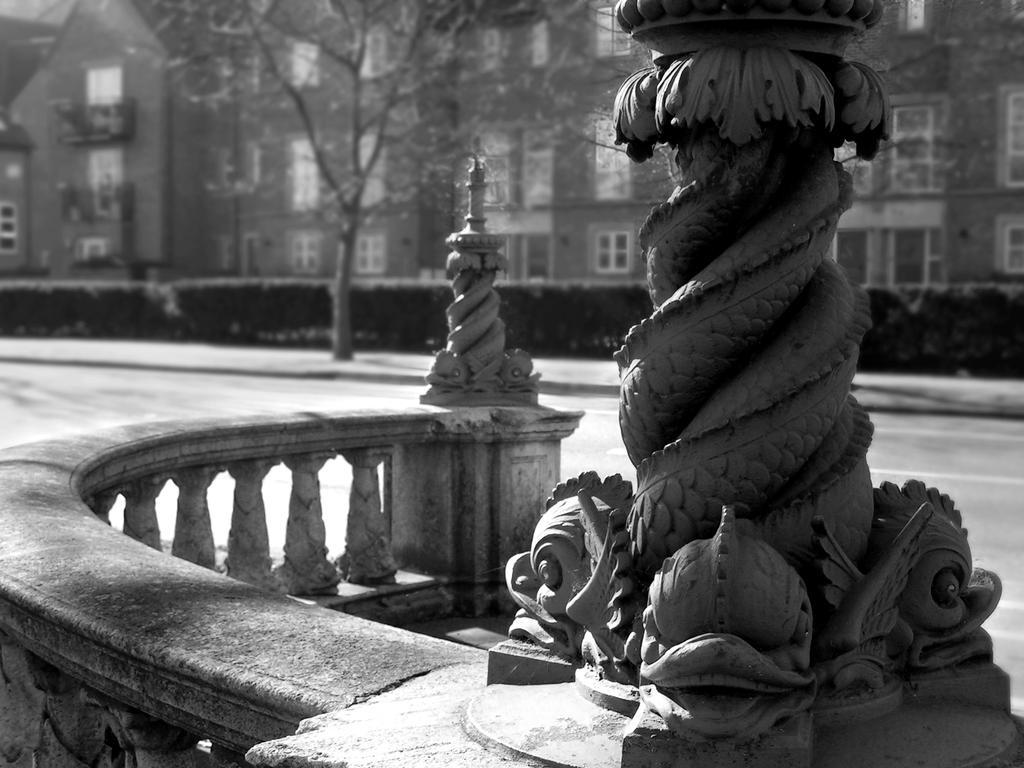Can you describe this image briefly? This is a black and white image. In this image we can see a statue and a barricade. On the backside we can see the road, a group of plants, trees and a building with some windows. 